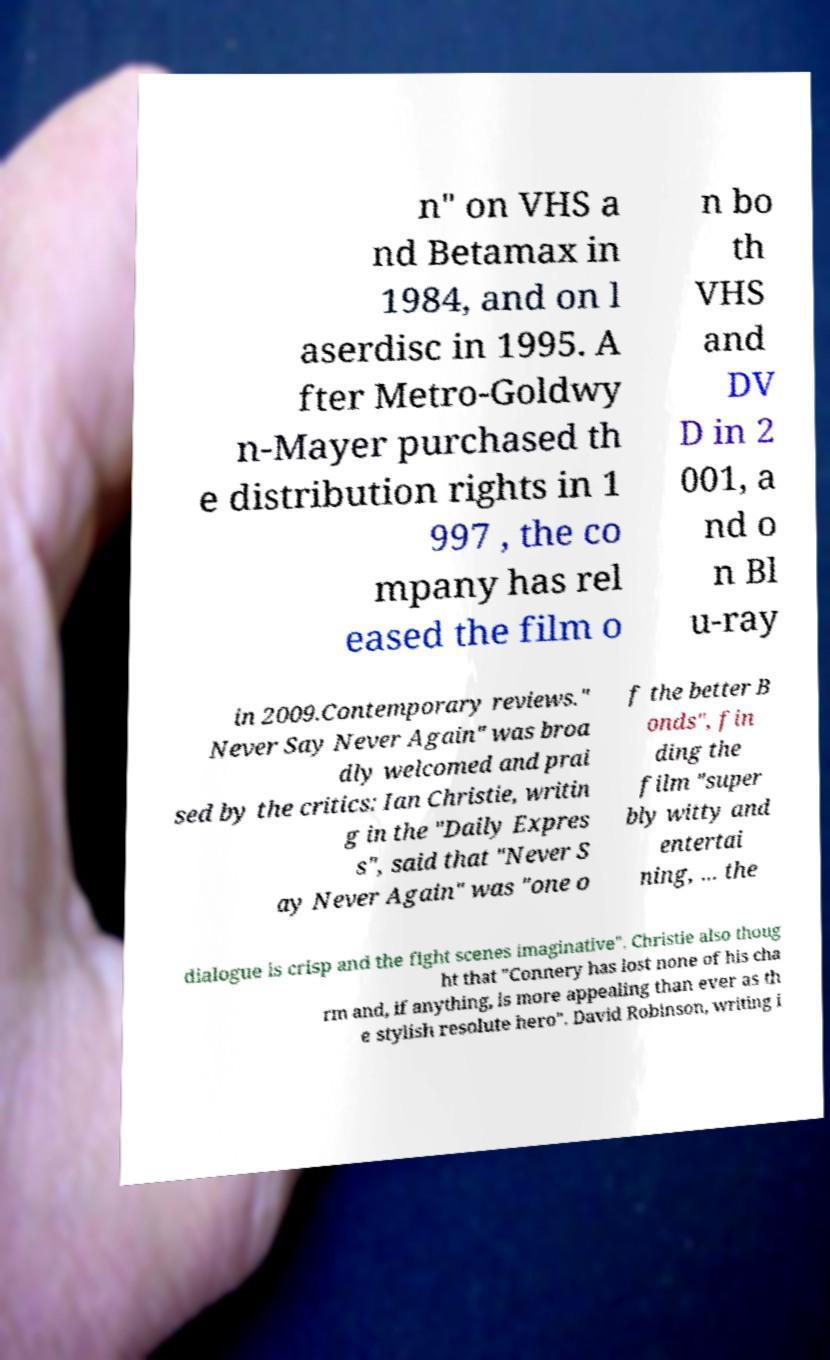Please identify and transcribe the text found in this image. n" on VHS a nd Betamax in 1984, and on l aserdisc in 1995. A fter Metro-Goldwy n-Mayer purchased th e distribution rights in 1 997 , the co mpany has rel eased the film o n bo th VHS and DV D in 2 001, a nd o n Bl u-ray in 2009.Contemporary reviews." Never Say Never Again" was broa dly welcomed and prai sed by the critics: Ian Christie, writin g in the "Daily Expres s", said that "Never S ay Never Again" was "one o f the better B onds", fin ding the film "super bly witty and entertai ning, ... the dialogue is crisp and the fight scenes imaginative". Christie also thoug ht that "Connery has lost none of his cha rm and, if anything, is more appealing than ever as th e stylish resolute hero". David Robinson, writing i 